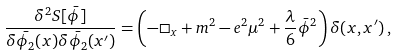Convert formula to latex. <formula><loc_0><loc_0><loc_500><loc_500>\frac { \delta ^ { 2 } S [ \bar { \phi } ] } { \delta \bar { \phi _ { 2 } } ( x ) \delta \bar { \phi _ { 2 } } ( x ^ { \prime } ) } = \left ( - \Box _ { x } + m ^ { 2 } - e ^ { 2 } \mu ^ { 2 } + \frac { \lambda } { 6 } \bar { \phi } ^ { 2 } \right ) \delta ( x , x ^ { \prime } ) \, ,</formula> 